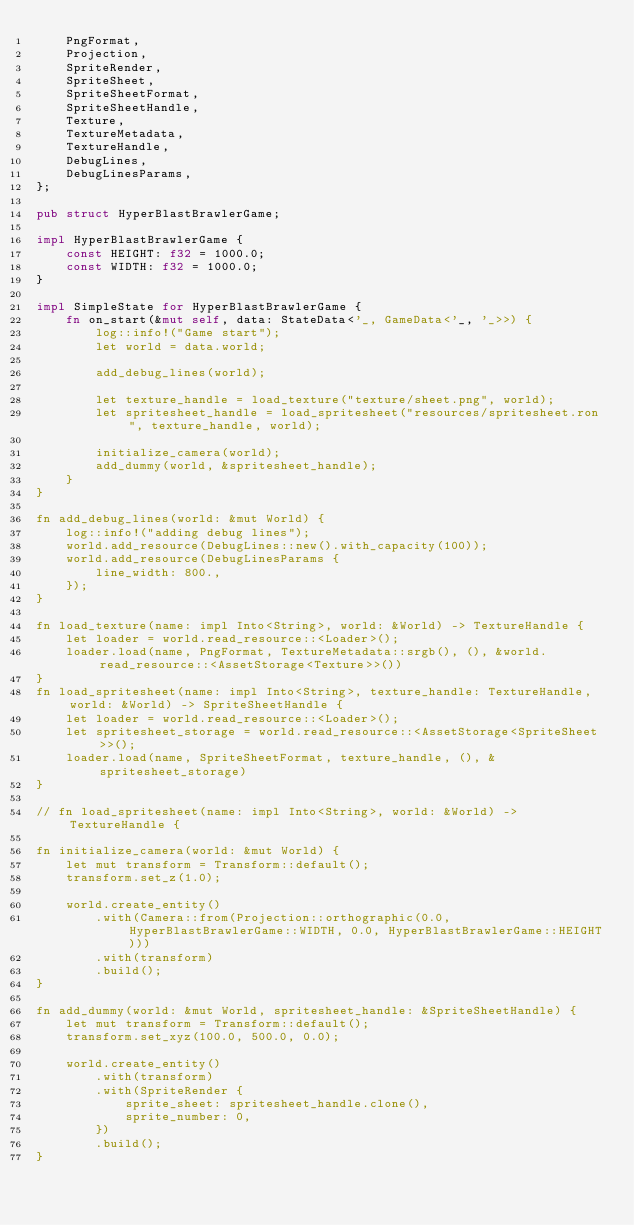<code> <loc_0><loc_0><loc_500><loc_500><_Rust_>    PngFormat,
    Projection,
    SpriteRender,
    SpriteSheet,
    SpriteSheetFormat,
    SpriteSheetHandle,
    Texture,
    TextureMetadata,
    TextureHandle,
    DebugLines,
    DebugLinesParams,
};

pub struct HyperBlastBrawlerGame;

impl HyperBlastBrawlerGame {
    const HEIGHT: f32 = 1000.0;
    const WIDTH: f32 = 1000.0;
}

impl SimpleState for HyperBlastBrawlerGame {
    fn on_start(&mut self, data: StateData<'_, GameData<'_, '_>>) {
        log::info!("Game start");
        let world = data.world;

        add_debug_lines(world);

        let texture_handle = load_texture("texture/sheet.png", world);
        let spritesheet_handle = load_spritesheet("resources/spritesheet.ron", texture_handle, world);

        initialize_camera(world);
        add_dummy(world, &spritesheet_handle);
    }
}

fn add_debug_lines(world: &mut World) {
    log::info!("adding debug lines");
    world.add_resource(DebugLines::new().with_capacity(100));
    world.add_resource(DebugLinesParams {
        line_width: 800.,
    });
}

fn load_texture(name: impl Into<String>, world: &World) -> TextureHandle {
    let loader = world.read_resource::<Loader>();
    loader.load(name, PngFormat, TextureMetadata::srgb(), (), &world.read_resource::<AssetStorage<Texture>>())
}
fn load_spritesheet(name: impl Into<String>, texture_handle: TextureHandle, world: &World) -> SpriteSheetHandle {
    let loader = world.read_resource::<Loader>();
    let spritesheet_storage = world.read_resource::<AssetStorage<SpriteSheet>>();
    loader.load(name, SpriteSheetFormat, texture_handle, (), &spritesheet_storage)
}

// fn load_spritesheet(name: impl Into<String>, world: &World) -> TextureHandle {

fn initialize_camera(world: &mut World) {
    let mut transform = Transform::default();
    transform.set_z(1.0);

    world.create_entity()
        .with(Camera::from(Projection::orthographic(0.0, HyperBlastBrawlerGame::WIDTH, 0.0, HyperBlastBrawlerGame::HEIGHT)))
        .with(transform)
        .build();
}

fn add_dummy(world: &mut World, spritesheet_handle: &SpriteSheetHandle) {
    let mut transform = Transform::default();
    transform.set_xyz(100.0, 500.0, 0.0);

    world.create_entity()
        .with(transform)
        .with(SpriteRender {
            sprite_sheet: spritesheet_handle.clone(),
            sprite_number: 0,
        })
        .build();
}
</code> 